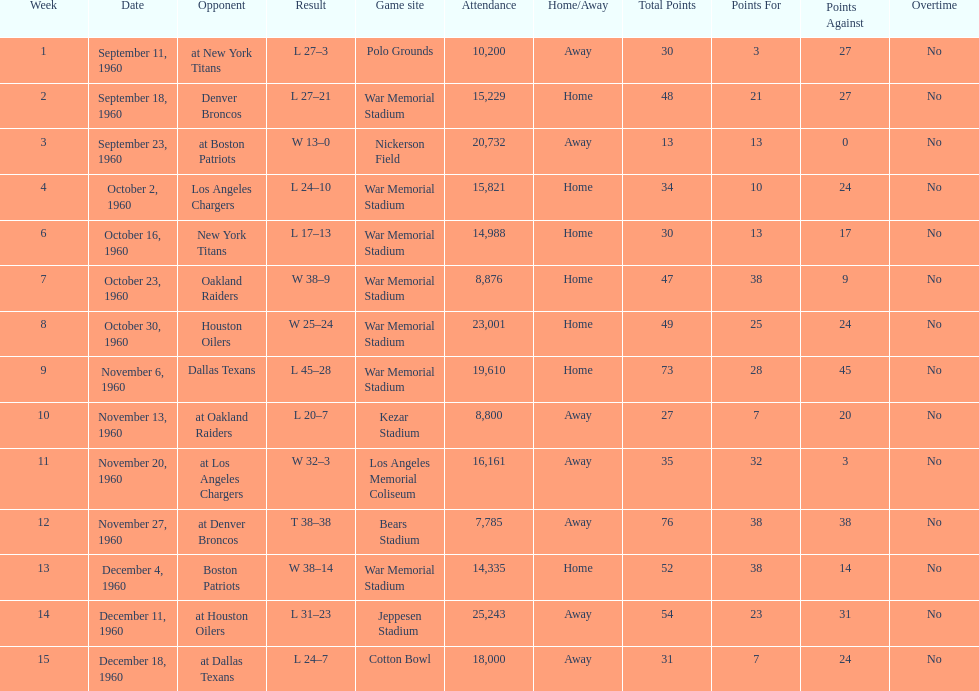Can you give me this table as a dict? {'header': ['Week', 'Date', 'Opponent', 'Result', 'Game site', 'Attendance', 'Home/Away', 'Total Points', 'Points For', 'Points Against', 'Overtime'], 'rows': [['1', 'September 11, 1960', 'at New York Titans', 'L 27–3', 'Polo Grounds', '10,200', 'Away', '30', '3', '27', 'No'], ['2', 'September 18, 1960', 'Denver Broncos', 'L 27–21', 'War Memorial Stadium', '15,229', 'Home', '48', '21', '27', 'No'], ['3', 'September 23, 1960', 'at Boston Patriots', 'W 13–0', 'Nickerson Field', '20,732', 'Away', '13', '13', '0', 'No'], ['4', 'October 2, 1960', 'Los Angeles Chargers', 'L 24–10', 'War Memorial Stadium', '15,821', 'Home', '34', '10', '24', 'No'], ['6', 'October 16, 1960', 'New York Titans', 'L 17–13', 'War Memorial Stadium', '14,988', 'Home', '30', '13', '17', 'No'], ['7', 'October 23, 1960', 'Oakland Raiders', 'W 38–9', 'War Memorial Stadium', '8,876', 'Home', '47', '38', '9', 'No'], ['8', 'October 30, 1960', 'Houston Oilers', 'W 25–24', 'War Memorial Stadium', '23,001', 'Home', '49', '25', '24', 'No'], ['9', 'November 6, 1960', 'Dallas Texans', 'L 45–28', 'War Memorial Stadium', '19,610', 'Home', '73', '28', '45', 'No'], ['10', 'November 13, 1960', 'at Oakland Raiders', 'L 20–7', 'Kezar Stadium', '8,800', 'Away', '27', '7', '20', 'No'], ['11', 'November 20, 1960', 'at Los Angeles Chargers', 'W 32–3', 'Los Angeles Memorial Coliseum', '16,161', 'Away', '35', '32', '3', 'No'], ['12', 'November 27, 1960', 'at Denver Broncos', 'T 38–38', 'Bears Stadium', '7,785', 'Away', '76', '38', '38', 'No'], ['13', 'December 4, 1960', 'Boston Patriots', 'W 38–14', 'War Memorial Stadium', '14,335', 'Home', '52', '38', '14', 'No'], ['14', 'December 11, 1960', 'at Houston Oilers', 'L 31–23', 'Jeppesen Stadium', '25,243', 'Away', '54', '23', '31', 'No'], ['15', 'December 18, 1960', 'at Dallas Texans', 'L 24–7', 'Cotton Bowl', '18,000', 'Away', '31', '7', '24', 'No']]} The total number of games played at war memorial stadium was how many? 7. 